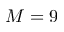Convert formula to latex. <formula><loc_0><loc_0><loc_500><loc_500>M = 9</formula> 